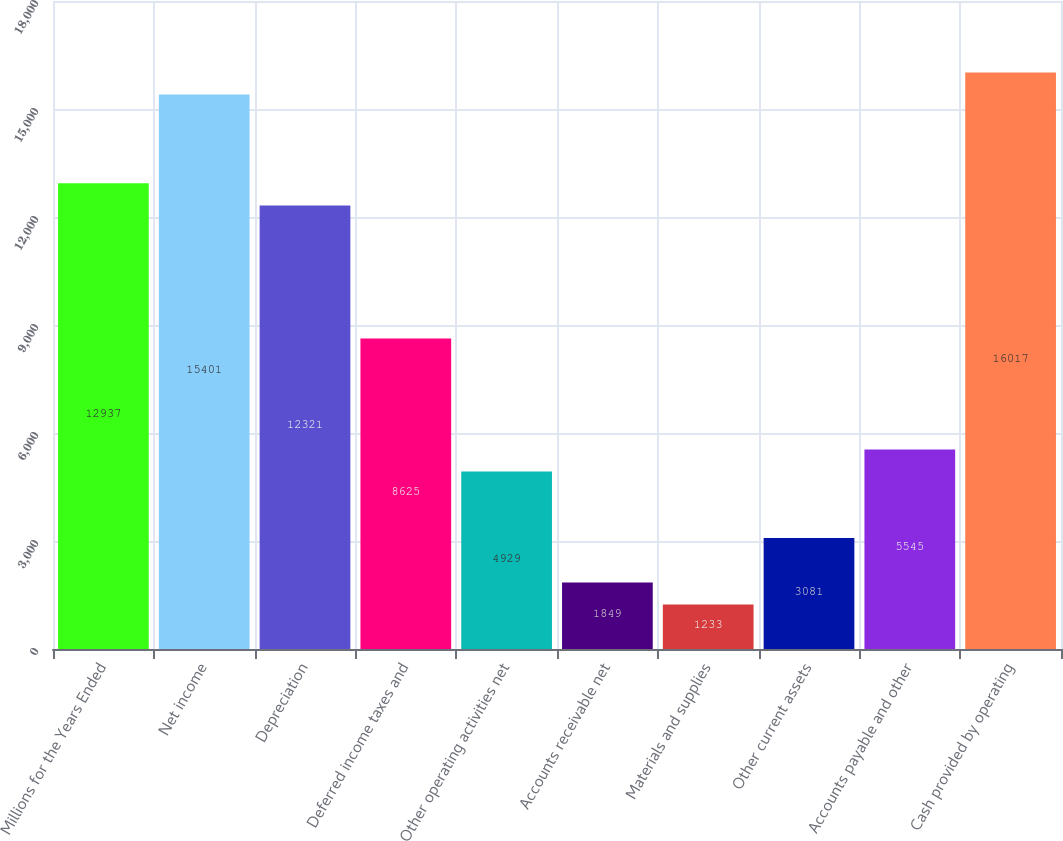<chart> <loc_0><loc_0><loc_500><loc_500><bar_chart><fcel>Millions for the Years Ended<fcel>Net income<fcel>Depreciation<fcel>Deferred income taxes and<fcel>Other operating activities net<fcel>Accounts receivable net<fcel>Materials and supplies<fcel>Other current assets<fcel>Accounts payable and other<fcel>Cash provided by operating<nl><fcel>12937<fcel>15401<fcel>12321<fcel>8625<fcel>4929<fcel>1849<fcel>1233<fcel>3081<fcel>5545<fcel>16017<nl></chart> 